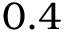Convert formula to latex. <formula><loc_0><loc_0><loc_500><loc_500>0 . 4</formula> 